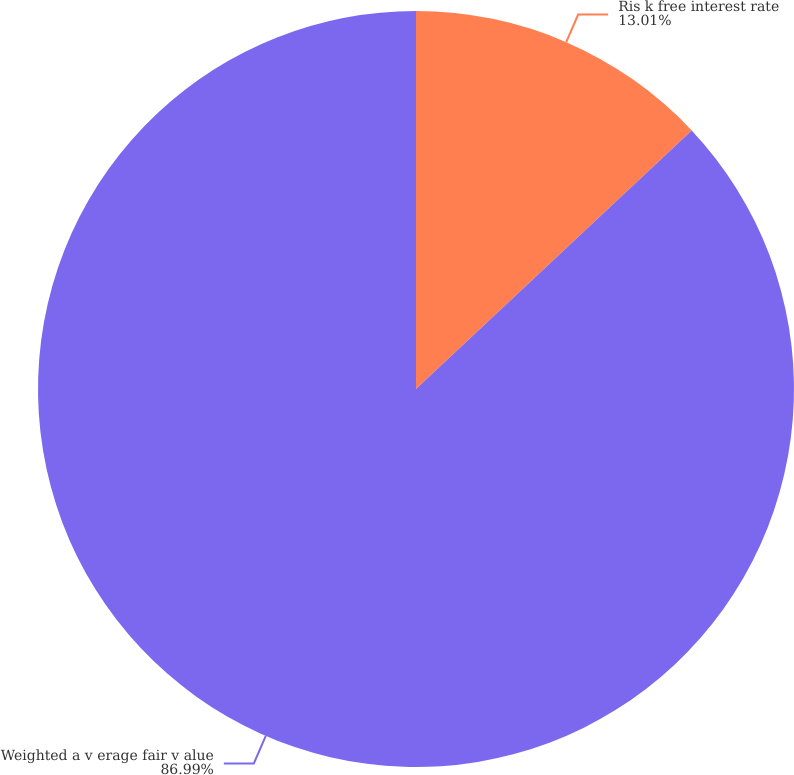Convert chart. <chart><loc_0><loc_0><loc_500><loc_500><pie_chart><fcel>Ris k free interest rate<fcel>Weighted a v erage fair v alue<nl><fcel>13.01%<fcel>86.99%<nl></chart> 